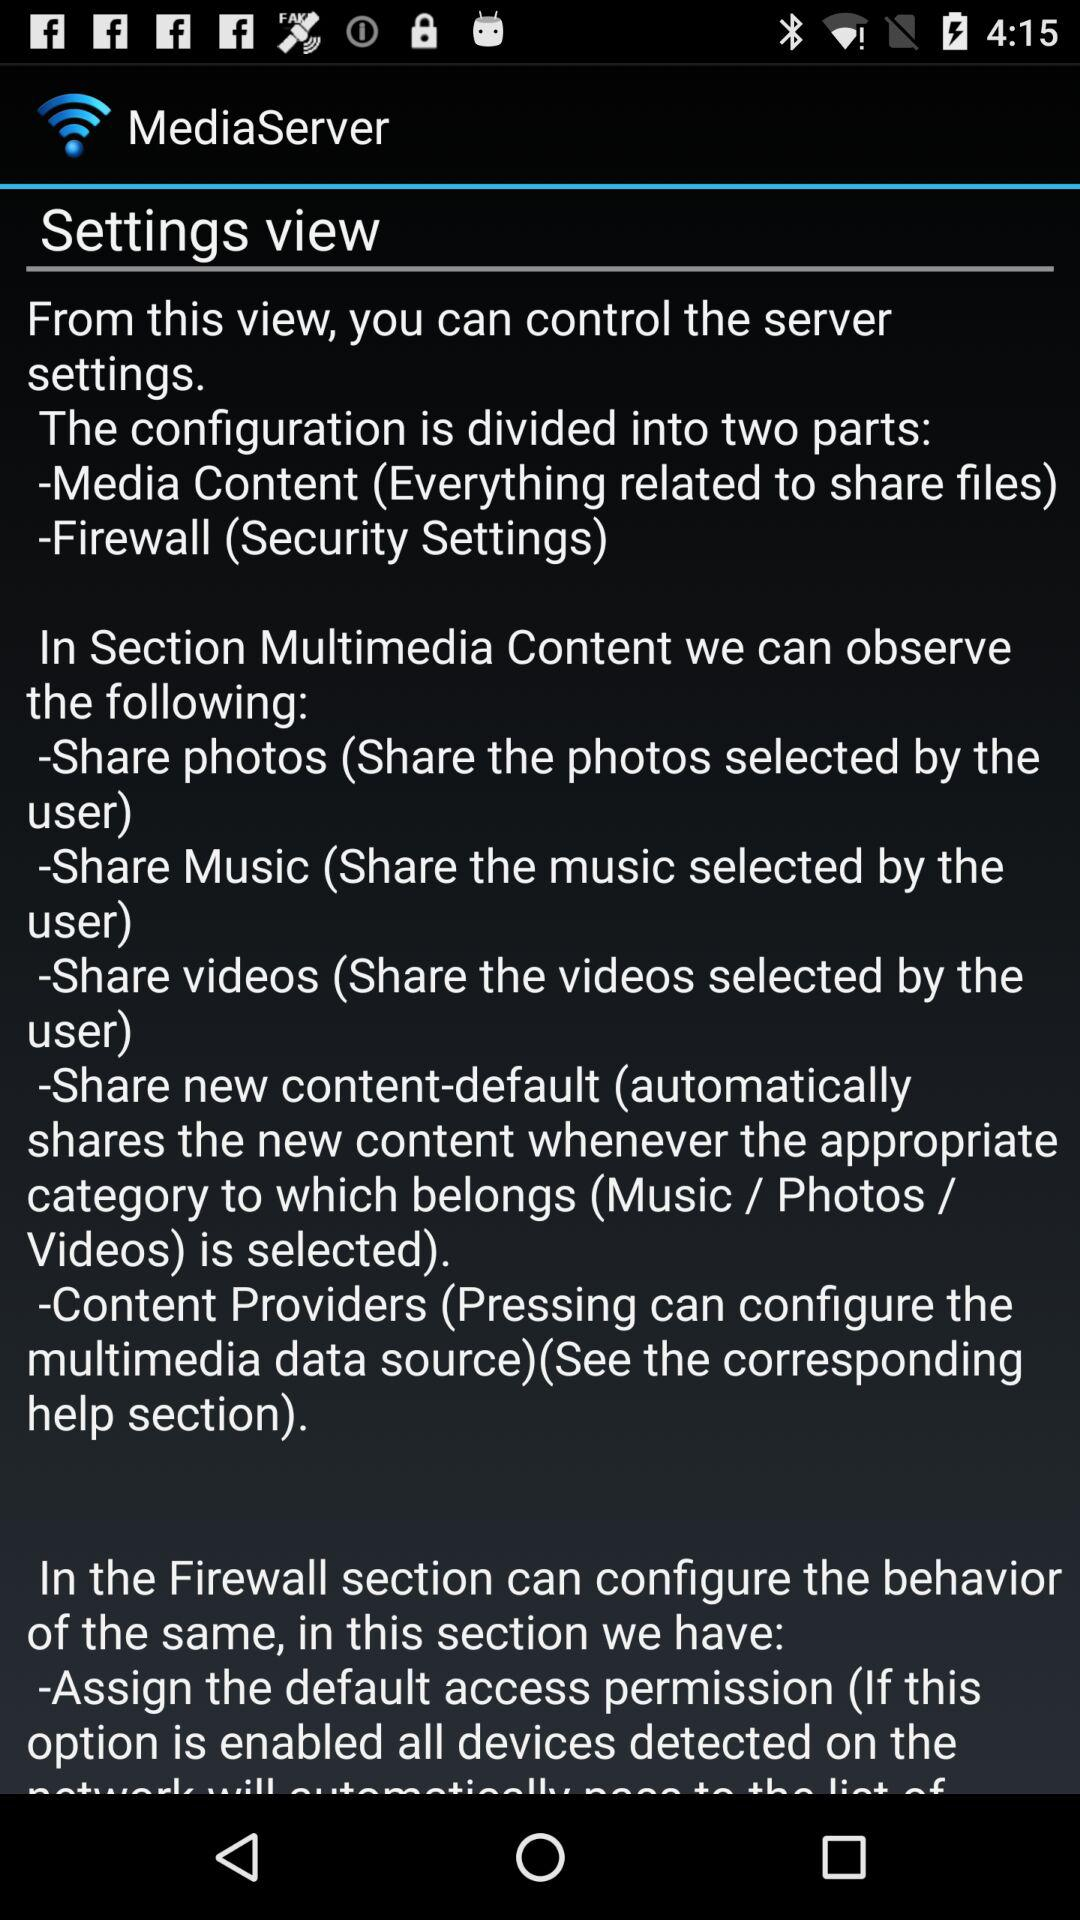What is the application name? The application name is "MediaServer". 